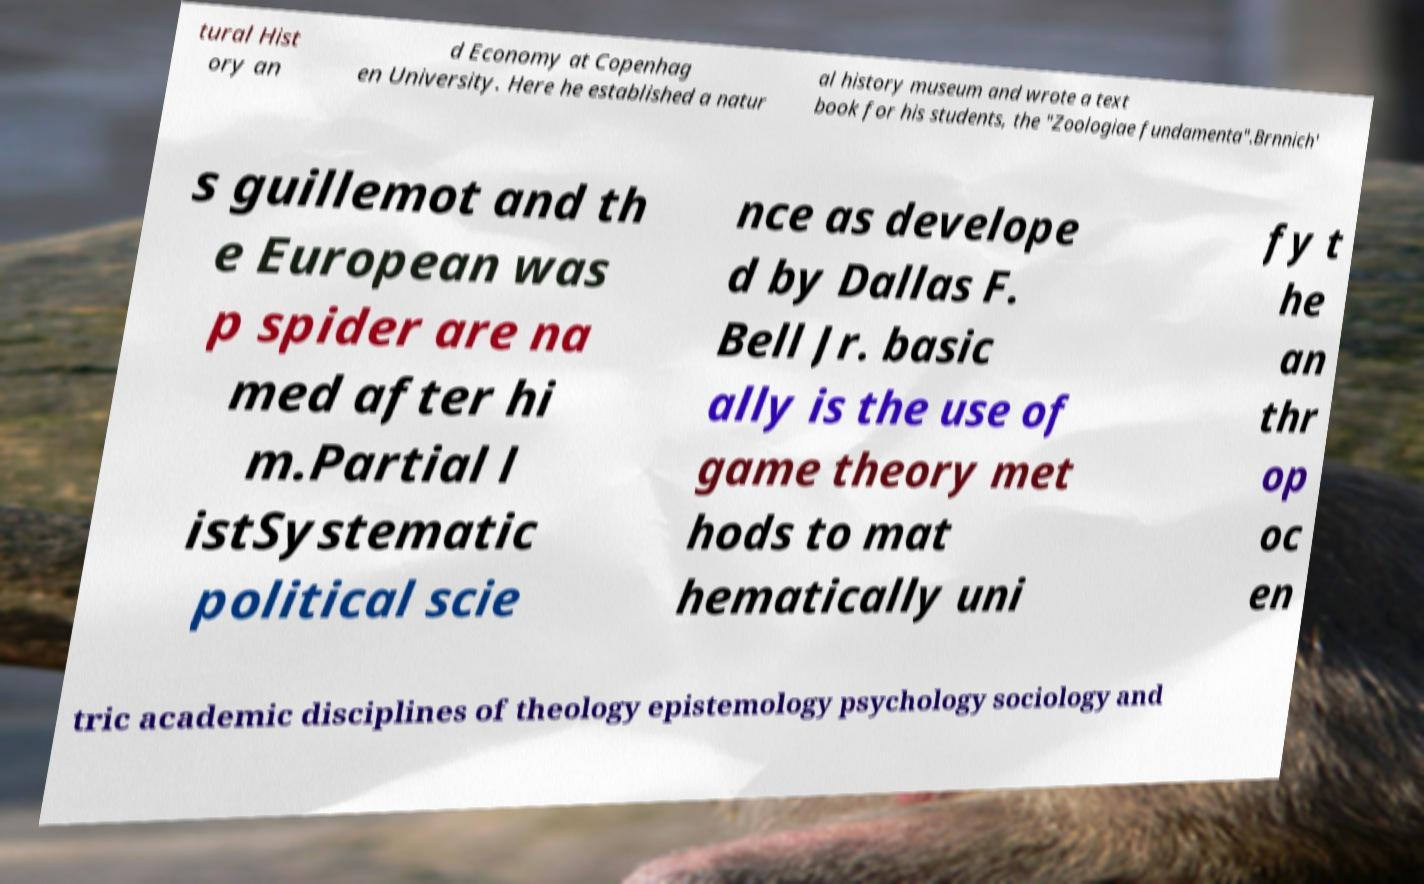Can you accurately transcribe the text from the provided image for me? tural Hist ory an d Economy at Copenhag en University. Here he established a natur al history museum and wrote a text book for his students, the "Zoologiae fundamenta".Brnnich' s guillemot and th e European was p spider are na med after hi m.Partial l istSystematic political scie nce as develope d by Dallas F. Bell Jr. basic ally is the use of game theory met hods to mat hematically uni fy t he an thr op oc en tric academic disciplines of theology epistemology psychology sociology and 